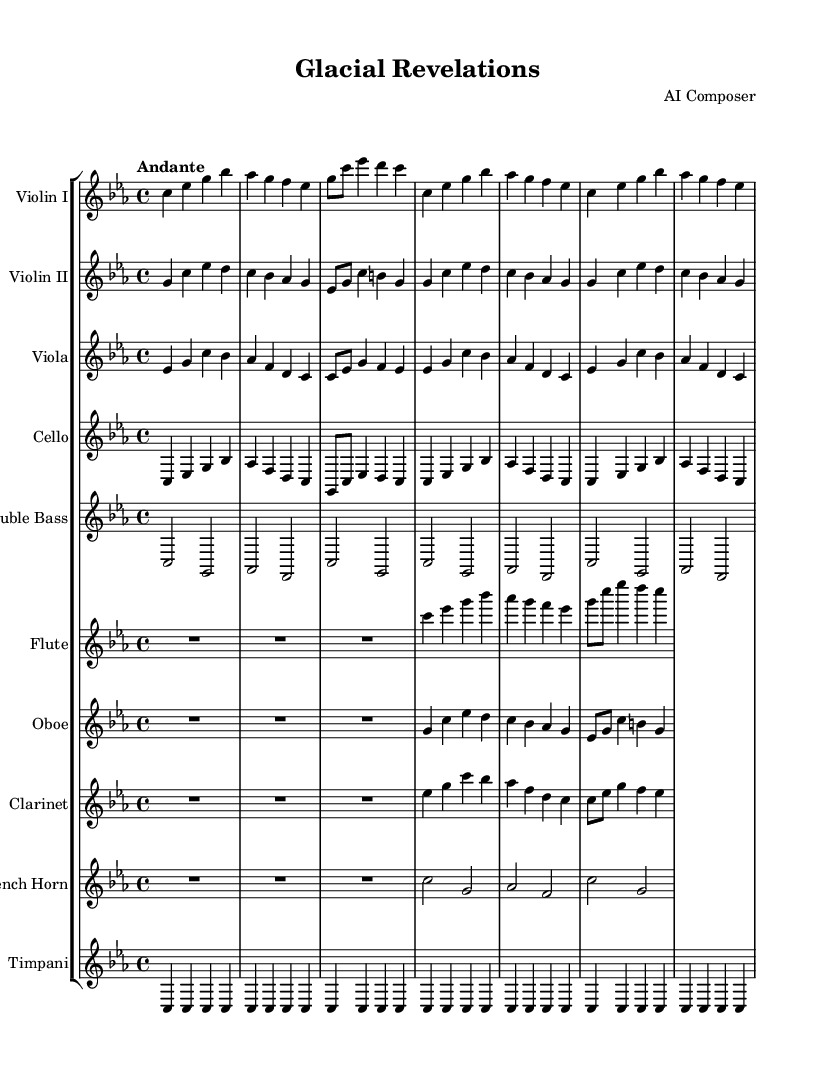What is the key signature of this music? The key signature is C minor, which has three flats: B flat, E flat, and A flat. This can be identified by looking at the key signature at the beginning of the score.
Answer: C minor What is the time signature of this music? The time signature is 4/4, indicating four beats per measure, and is seen at the beginning of the score right next to the key signature.
Answer: 4/4 What is the tempo marking for the piece? The tempo marking "Andante" indicates a moderately slow tempo, which is specified just below the time signature at the beginning of the score.
Answer: Andante How many measures does each instrument play in the first pattern? Each instrument plays 6 measures in the first pattern as indicated by the repeated section that unfolds for 2 times, suggesting a total of 3 measures is played twice.
Answer: 6 Which instrument has the longest note in the measure? The double bass has whole notes which last longer than any other notes in the measure, showing that it plays the lowest pitches. This can be determined by observing the note values throughout the score.
Answer: Double Bass What type of ensemble is represented in this symphony? The ensemble is a symphonic orchestra consisting of string and woodwind instruments, along with percussion. This is derived from the combination of the various instruments mentioned in the score.
Answer: Symphonic Orchestra Which section of the music features the flute? The flute plays primarily at the beginning and has a rest for the first three beats followed by melodic phrases; this can be determined by its notation in the score.
Answer: Beginning 